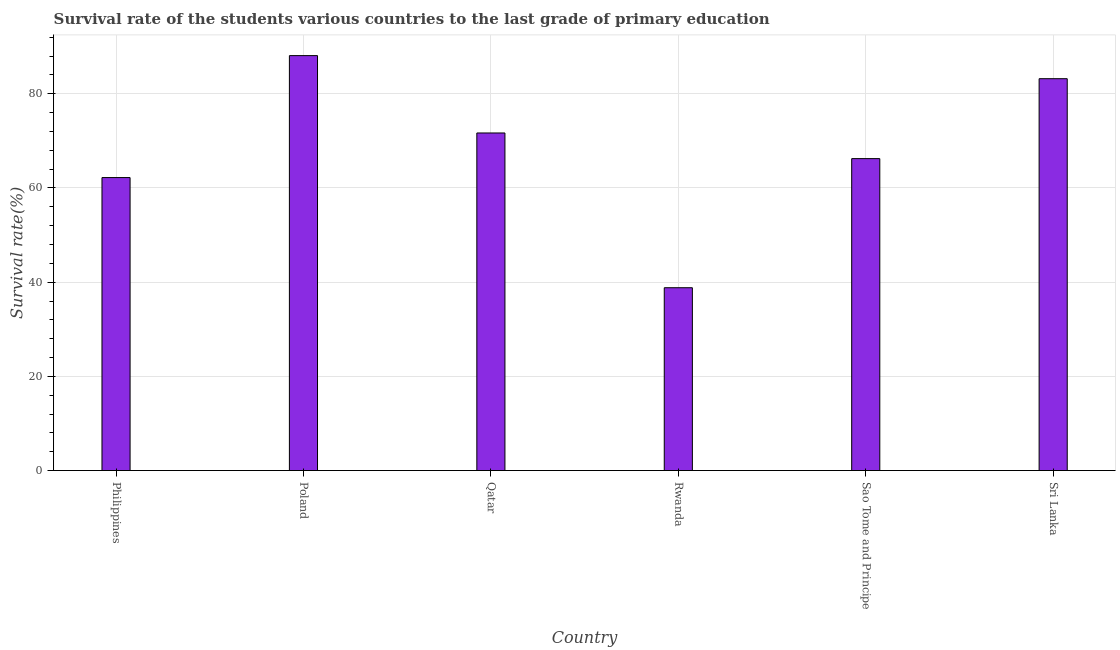What is the title of the graph?
Provide a short and direct response. Survival rate of the students various countries to the last grade of primary education. What is the label or title of the X-axis?
Keep it short and to the point. Country. What is the label or title of the Y-axis?
Keep it short and to the point. Survival rate(%). What is the survival rate in primary education in Rwanda?
Ensure brevity in your answer.  38.82. Across all countries, what is the maximum survival rate in primary education?
Give a very brief answer. 88.1. Across all countries, what is the minimum survival rate in primary education?
Provide a succinct answer. 38.82. In which country was the survival rate in primary education minimum?
Make the answer very short. Rwanda. What is the sum of the survival rate in primary education?
Your response must be concise. 410.26. What is the difference between the survival rate in primary education in Qatar and Sao Tome and Principe?
Provide a short and direct response. 5.45. What is the average survival rate in primary education per country?
Ensure brevity in your answer.  68.38. What is the median survival rate in primary education?
Keep it short and to the point. 68.96. In how many countries, is the survival rate in primary education greater than 4 %?
Offer a terse response. 6. What is the ratio of the survival rate in primary education in Poland to that in Sri Lanka?
Provide a succinct answer. 1.06. Is the difference between the survival rate in primary education in Qatar and Rwanda greater than the difference between any two countries?
Offer a very short reply. No. What is the difference between the highest and the second highest survival rate in primary education?
Ensure brevity in your answer.  4.9. Is the sum of the survival rate in primary education in Poland and Qatar greater than the maximum survival rate in primary education across all countries?
Your answer should be compact. Yes. What is the difference between the highest and the lowest survival rate in primary education?
Your response must be concise. 49.28. In how many countries, is the survival rate in primary education greater than the average survival rate in primary education taken over all countries?
Give a very brief answer. 3. Are the values on the major ticks of Y-axis written in scientific E-notation?
Make the answer very short. No. What is the Survival rate(%) in Philippines?
Keep it short and to the point. 62.21. What is the Survival rate(%) in Poland?
Your answer should be very brief. 88.1. What is the Survival rate(%) of Qatar?
Offer a terse response. 71.68. What is the Survival rate(%) of Rwanda?
Your answer should be compact. 38.82. What is the Survival rate(%) in Sao Tome and Principe?
Give a very brief answer. 66.24. What is the Survival rate(%) of Sri Lanka?
Offer a very short reply. 83.21. What is the difference between the Survival rate(%) in Philippines and Poland?
Give a very brief answer. -25.89. What is the difference between the Survival rate(%) in Philippines and Qatar?
Provide a short and direct response. -9.47. What is the difference between the Survival rate(%) in Philippines and Rwanda?
Ensure brevity in your answer.  23.39. What is the difference between the Survival rate(%) in Philippines and Sao Tome and Principe?
Offer a terse response. -4.02. What is the difference between the Survival rate(%) in Philippines and Sri Lanka?
Your answer should be compact. -20.99. What is the difference between the Survival rate(%) in Poland and Qatar?
Make the answer very short. 16.42. What is the difference between the Survival rate(%) in Poland and Rwanda?
Give a very brief answer. 49.28. What is the difference between the Survival rate(%) in Poland and Sao Tome and Principe?
Ensure brevity in your answer.  21.87. What is the difference between the Survival rate(%) in Poland and Sri Lanka?
Provide a short and direct response. 4.9. What is the difference between the Survival rate(%) in Qatar and Rwanda?
Your answer should be very brief. 32.86. What is the difference between the Survival rate(%) in Qatar and Sao Tome and Principe?
Ensure brevity in your answer.  5.45. What is the difference between the Survival rate(%) in Qatar and Sri Lanka?
Provide a short and direct response. -11.52. What is the difference between the Survival rate(%) in Rwanda and Sao Tome and Principe?
Provide a succinct answer. -27.41. What is the difference between the Survival rate(%) in Rwanda and Sri Lanka?
Keep it short and to the point. -44.38. What is the difference between the Survival rate(%) in Sao Tome and Principe and Sri Lanka?
Provide a short and direct response. -16.97. What is the ratio of the Survival rate(%) in Philippines to that in Poland?
Keep it short and to the point. 0.71. What is the ratio of the Survival rate(%) in Philippines to that in Qatar?
Ensure brevity in your answer.  0.87. What is the ratio of the Survival rate(%) in Philippines to that in Rwanda?
Give a very brief answer. 1.6. What is the ratio of the Survival rate(%) in Philippines to that in Sao Tome and Principe?
Offer a terse response. 0.94. What is the ratio of the Survival rate(%) in Philippines to that in Sri Lanka?
Ensure brevity in your answer.  0.75. What is the ratio of the Survival rate(%) in Poland to that in Qatar?
Your response must be concise. 1.23. What is the ratio of the Survival rate(%) in Poland to that in Rwanda?
Offer a terse response. 2.27. What is the ratio of the Survival rate(%) in Poland to that in Sao Tome and Principe?
Provide a short and direct response. 1.33. What is the ratio of the Survival rate(%) in Poland to that in Sri Lanka?
Give a very brief answer. 1.06. What is the ratio of the Survival rate(%) in Qatar to that in Rwanda?
Your answer should be compact. 1.85. What is the ratio of the Survival rate(%) in Qatar to that in Sao Tome and Principe?
Provide a short and direct response. 1.08. What is the ratio of the Survival rate(%) in Qatar to that in Sri Lanka?
Make the answer very short. 0.86. What is the ratio of the Survival rate(%) in Rwanda to that in Sao Tome and Principe?
Provide a succinct answer. 0.59. What is the ratio of the Survival rate(%) in Rwanda to that in Sri Lanka?
Provide a succinct answer. 0.47. What is the ratio of the Survival rate(%) in Sao Tome and Principe to that in Sri Lanka?
Offer a terse response. 0.8. 